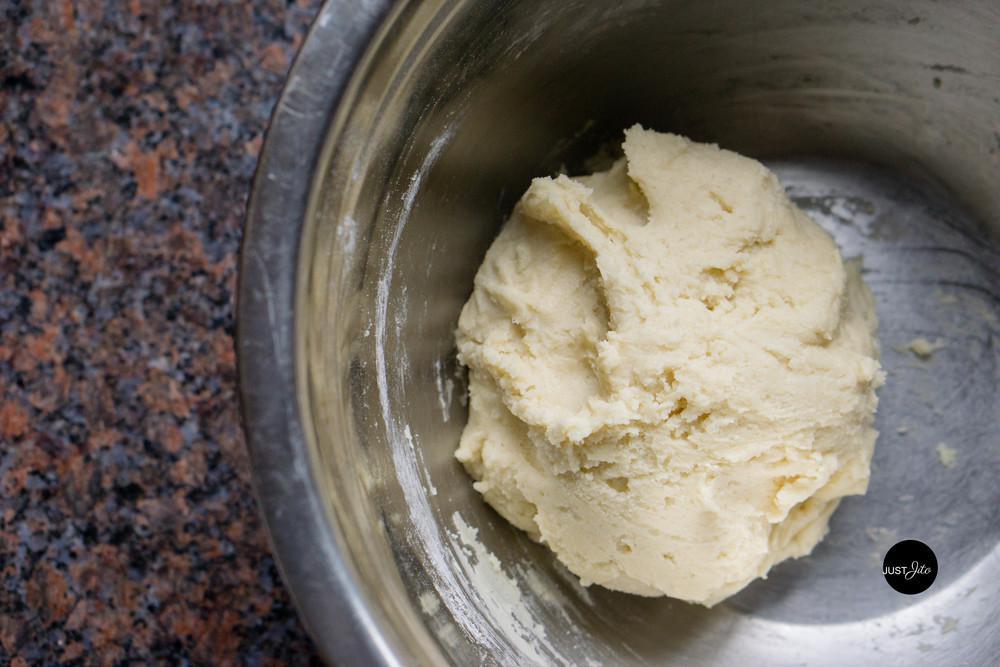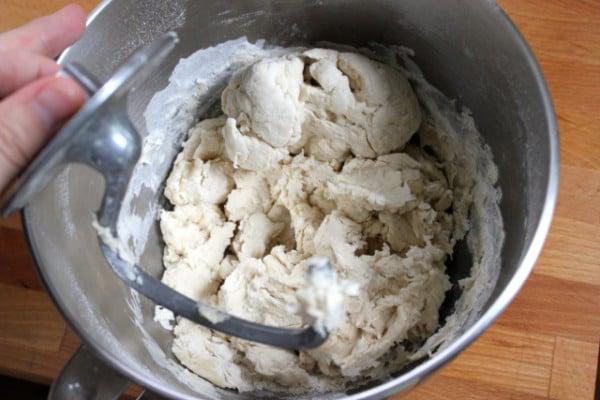The first image is the image on the left, the second image is the image on the right. For the images displayed, is the sentence "In at least one image there is a utenical in a silver mixing bowl." factually correct? Answer yes or no. Yes. The first image is the image on the left, the second image is the image on the right. Analyze the images presented: Is the assertion "There is a utensil in some dough." valid? Answer yes or no. Yes. 